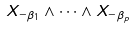<formula> <loc_0><loc_0><loc_500><loc_500>X _ { - \beta _ { 1 } } \wedge \dots \wedge X _ { - \beta _ { p } }</formula> 